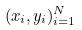<formula> <loc_0><loc_0><loc_500><loc_500>( x _ { i } , y _ { i } ) _ { i = 1 } ^ { N }</formula> 